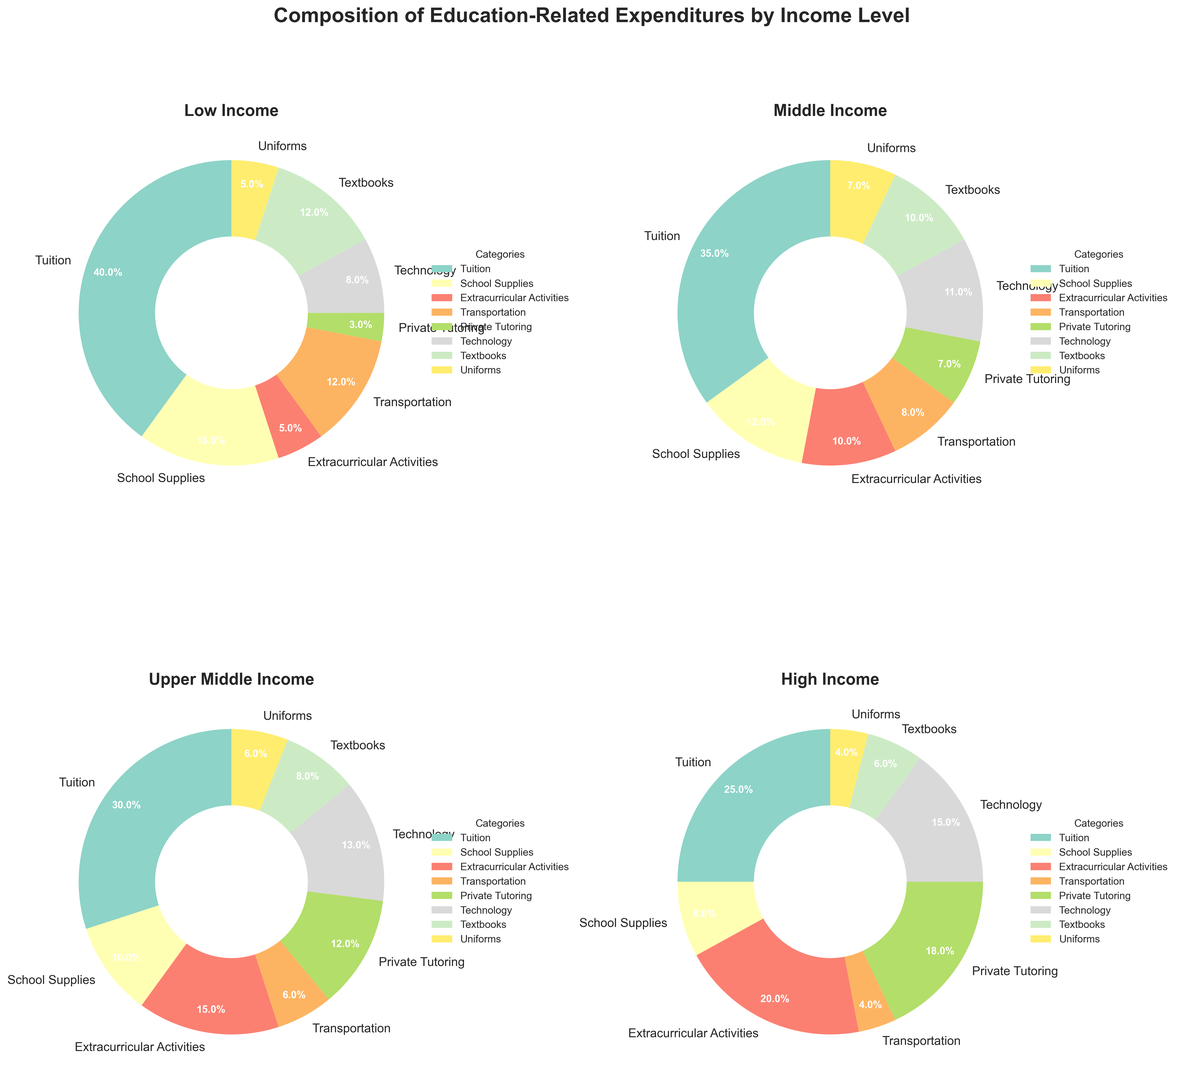Which income level spends the highest percentage on private tutoring? The High Income group has a wedge labeled 'Private Tutoring' that takes up a larger portion and is labeled 18% compared to the other income levels.
Answer: High Income What is the combined percentage of tuition and transportation expenses for the Low Income group? From the pie chart, the Low Income group spends 40% on Tuition and 12% on Transportation. Adding these up gives 40% + 12% = 52%.
Answer: 52% Which category shows an increasing percentage as income level increases when examining all income groups in the chart? By examining each pie chart, Private Tutoring shows an increase: Low (3%), Middle (7%), Upper Middle (12%), and High Income (18%).
Answer: Private Tutoring How do the expenditures on technology compare between Low Income and High Income groups? According to the pie charts, Low Income spends 8% on Technology, and High Income spends 15%. Comparing these, 15% is greater than 8%.
Answer: High Income spends more Which two categories have the same expenditure percentage in the Middle Income group? In the Middle Income chart, School Supplies and Textbooks both are labeled as 10%.
Answer: School Supplies and Textbooks What is the difference in the percentage of spending on extracurricular activities between Upper Middle Income and Low Income groups? The Upper Middle Income group spends 15% on Extracurricular Activities, and the Low Income group spends 5%. The difference is 15% - 5% = 10%.
Answer: 10% Which income level has the smallest expenditure on transportation, and what is the percentage? By reviewing all the pie charts, the High Income group spends the smallest portion on Transportation labeled as 4%.
Answer: High Income, 4% How do school supplies expenditures vary from Low Income to High Income levels? According to the pie charts, school supplies percentages are: Low (15%), Middle (12%), Upper Middle (10%), High (8%). The percentage decreases as income level increases.
Answer: Decreases 